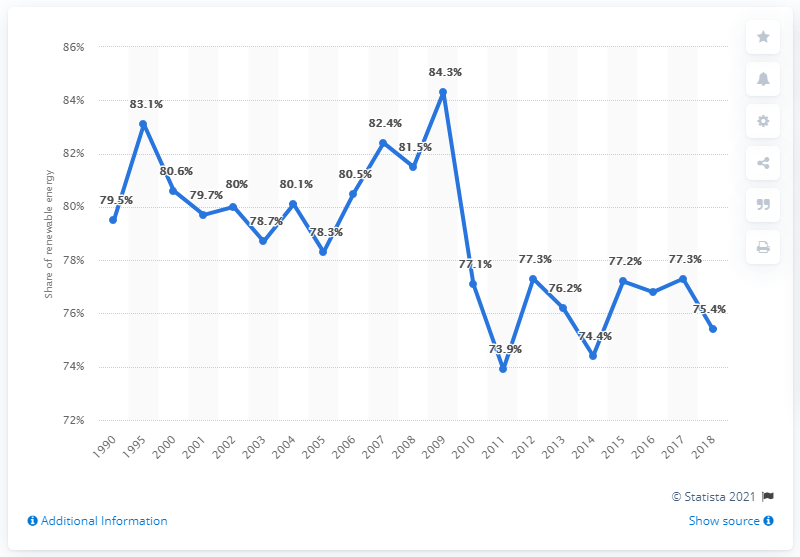Draw attention to some important aspects in this diagram. In 2018, Nigeria's primary energy consumption was 75.4%. 